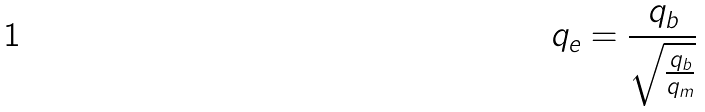Convert formula to latex. <formula><loc_0><loc_0><loc_500><loc_500>q _ { e } = \frac { q _ { b } } { \sqrt { \frac { q _ { b } } { q _ { m } } } }</formula> 